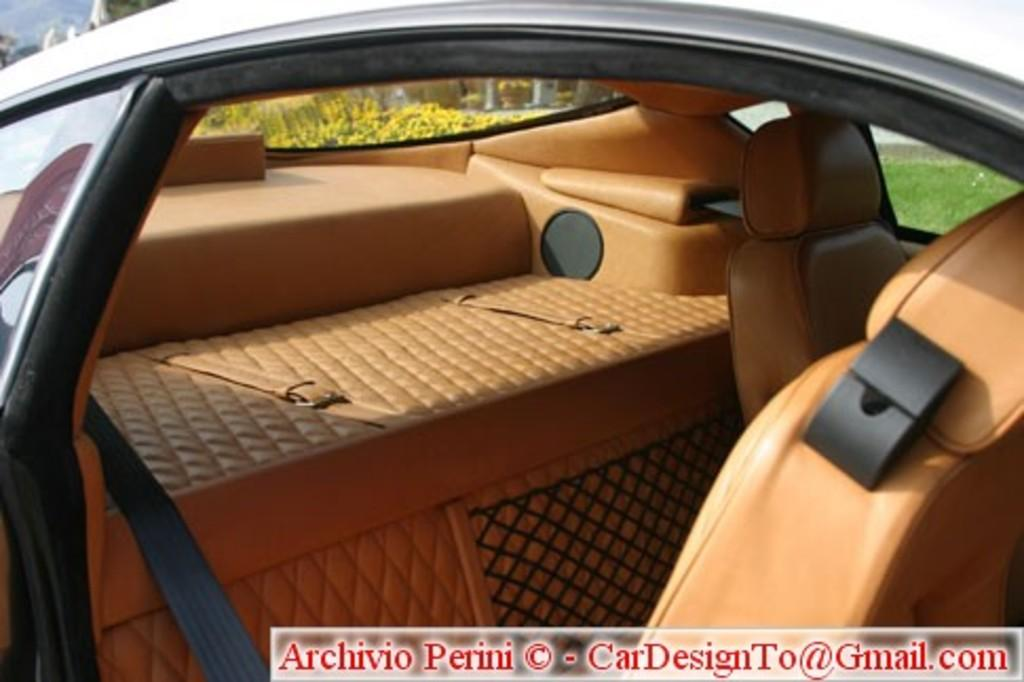What type of setting is shown in the image? The image shows an inner view of a car. What can be seen outside the car in the image? There is grass visible on the backside of the car. What is visible above the car in the image? The sky is visible in the image. What class of car is being described in the caption of the image? There is no caption present in the image, so it is not possible to determine the class of the car from the image alone. 